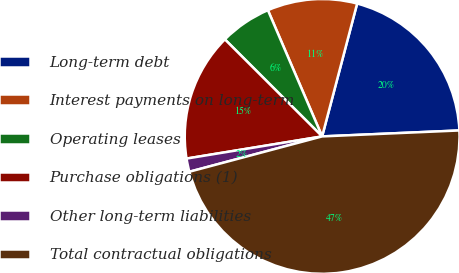Convert chart to OTSL. <chart><loc_0><loc_0><loc_500><loc_500><pie_chart><fcel>Long-term debt<fcel>Interest payments on long-term<fcel>Operating leases<fcel>Purchase obligations (1)<fcel>Other long-term liabilities<fcel>Total contractual obligations<nl><fcel>20.21%<fcel>10.56%<fcel>6.06%<fcel>15.06%<fcel>1.56%<fcel>46.55%<nl></chart> 